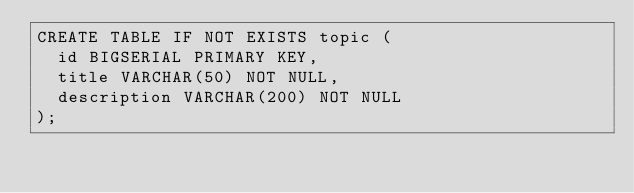<code> <loc_0><loc_0><loc_500><loc_500><_SQL_>CREATE TABLE IF NOT EXISTS topic (
  id BIGSERIAL PRIMARY KEY,
  title VARCHAR(50) NOT NULL,
  description VARCHAR(200) NOT NULL
);
</code> 